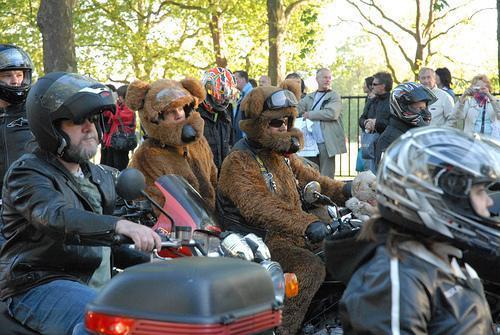How many motorcycles are there?
Give a very brief answer. 2. How many people are there?
Give a very brief answer. 9. How many books are on the table?
Give a very brief answer. 0. 